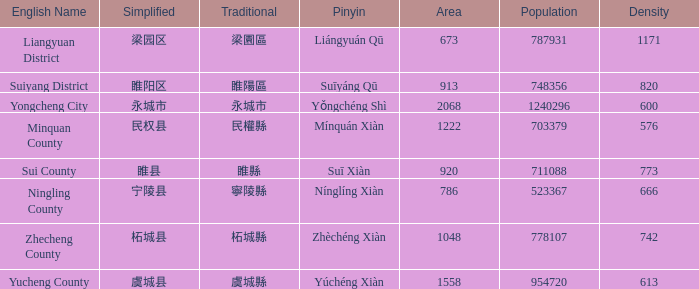What is the Pinyin for the simplified 虞城县? Yúchéng Xiàn. 